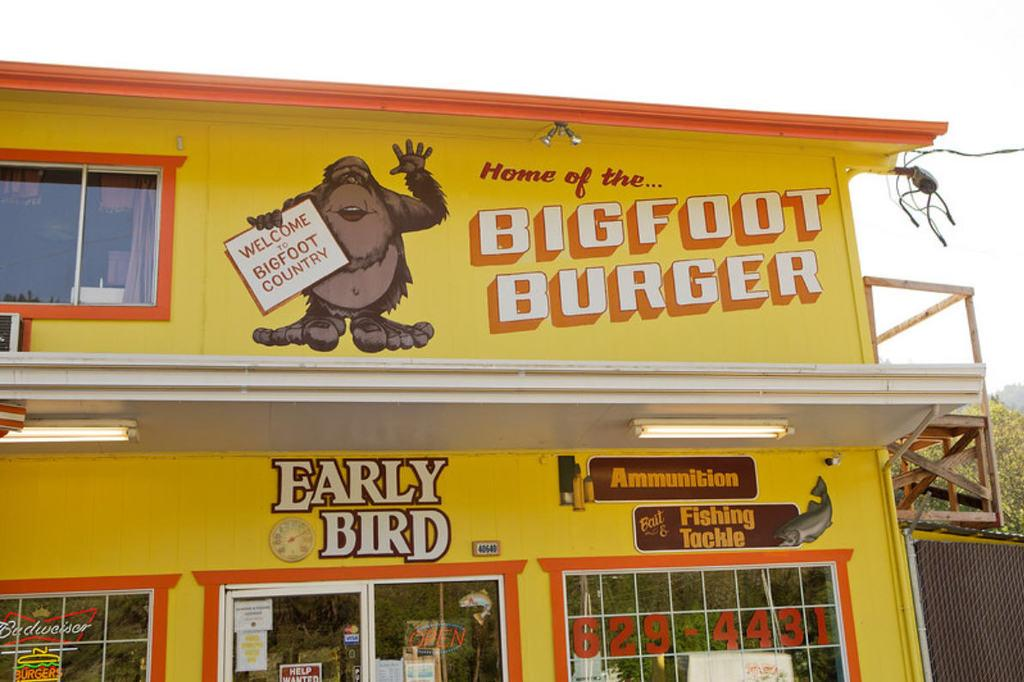What is the color of the store in the image? The store is yellow in color. What can be seen inside the store? There are pictures inside the store. What is visible at the top of the image? The sky is visible at the top of the image. What type of story is being told by the bear inside the store? There is no bear present inside the store; it only features a yellow store with pictures inside. 